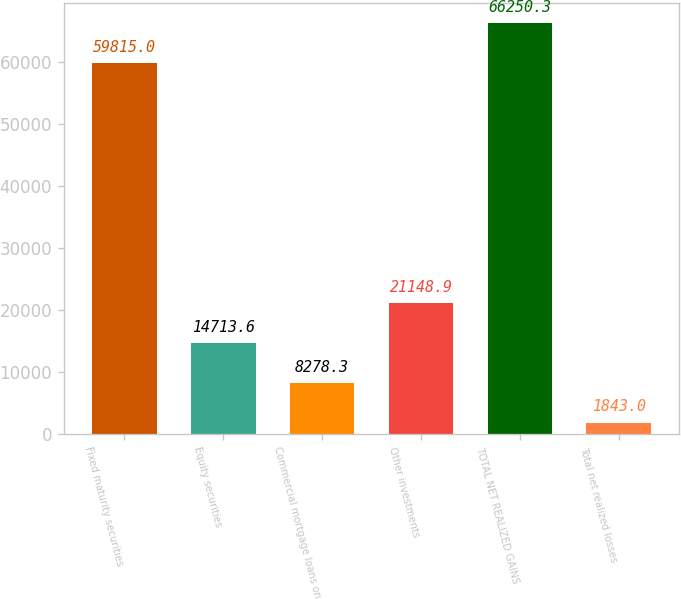Convert chart. <chart><loc_0><loc_0><loc_500><loc_500><bar_chart><fcel>Fixed maturity securities<fcel>Equity securities<fcel>Commercial mortgage loans on<fcel>Other investments<fcel>TOTAL NET REALIZED GAINS<fcel>Total net realized losses<nl><fcel>59815<fcel>14713.6<fcel>8278.3<fcel>21148.9<fcel>66250.3<fcel>1843<nl></chart> 